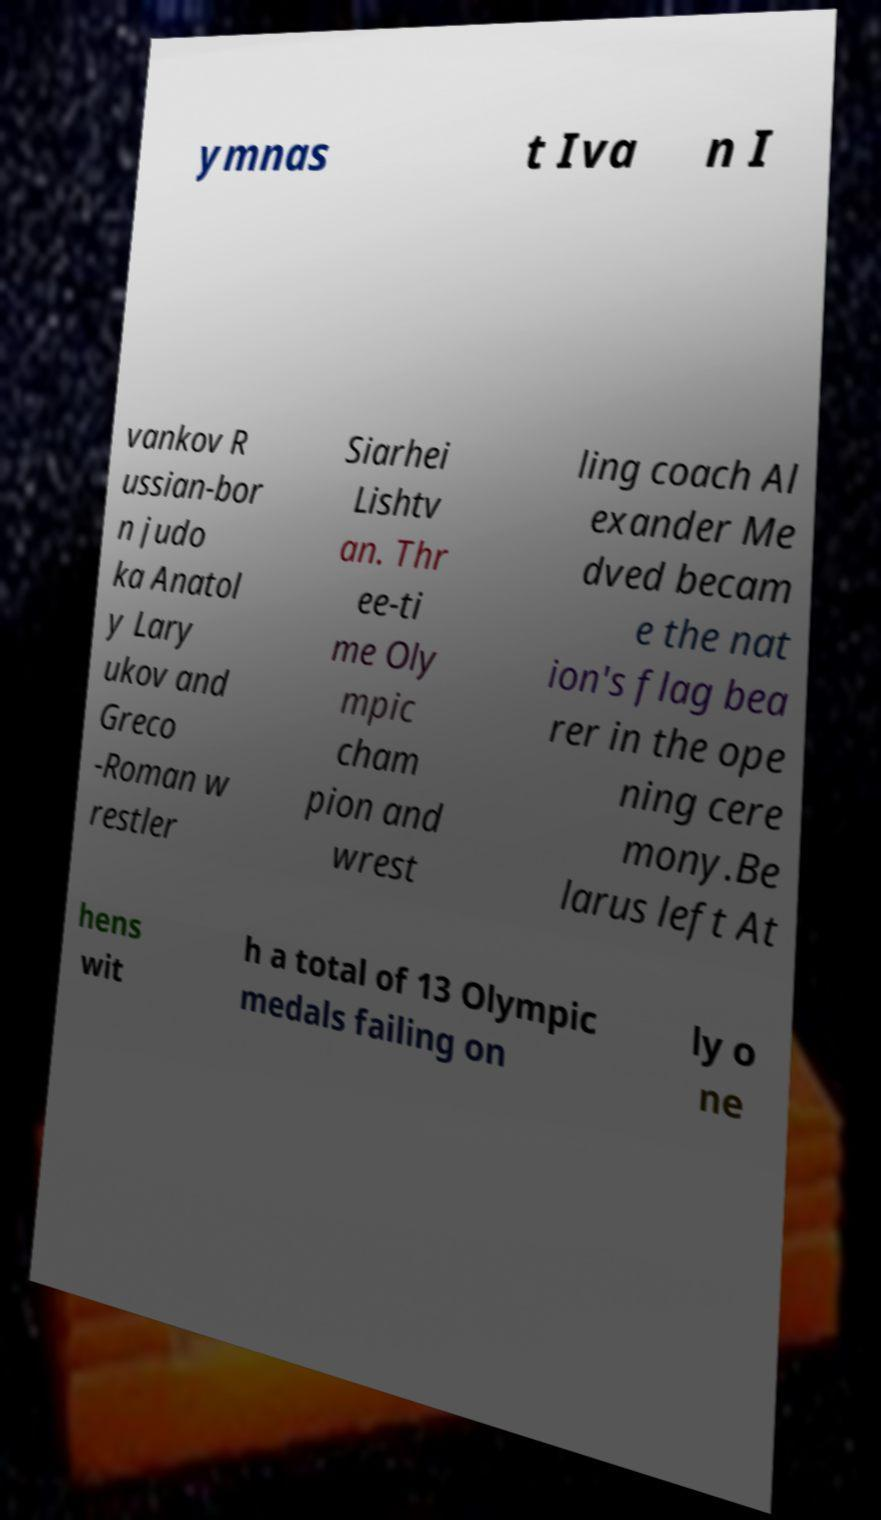For documentation purposes, I need the text within this image transcribed. Could you provide that? ymnas t Iva n I vankov R ussian-bor n judo ka Anatol y Lary ukov and Greco -Roman w restler Siarhei Lishtv an. Thr ee-ti me Oly mpic cham pion and wrest ling coach Al exander Me dved becam e the nat ion's flag bea rer in the ope ning cere mony.Be larus left At hens wit h a total of 13 Olympic medals failing on ly o ne 